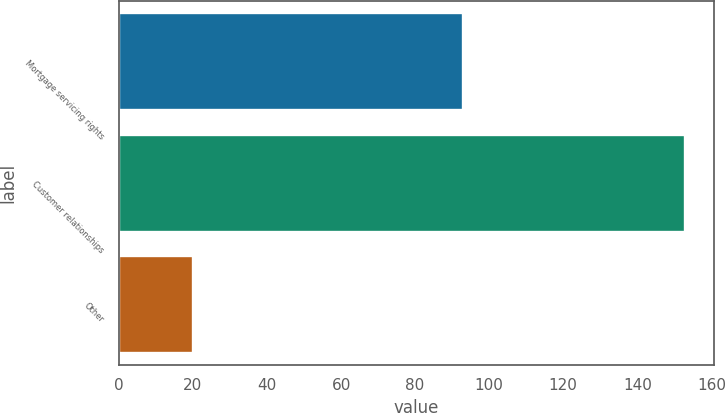Convert chart. <chart><loc_0><loc_0><loc_500><loc_500><bar_chart><fcel>Mortgage servicing rights<fcel>Customer relationships<fcel>Other<nl><fcel>93<fcel>153<fcel>20<nl></chart> 